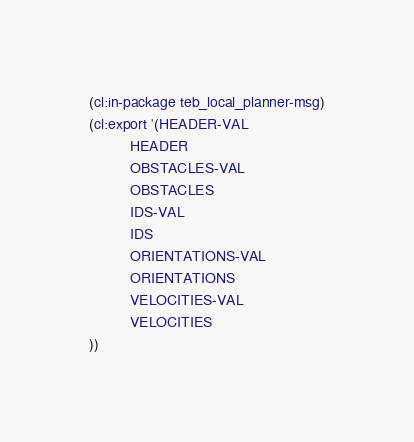<code> <loc_0><loc_0><loc_500><loc_500><_Lisp_>(cl:in-package teb_local_planner-msg)
(cl:export '(HEADER-VAL
          HEADER
          OBSTACLES-VAL
          OBSTACLES
          IDS-VAL
          IDS
          ORIENTATIONS-VAL
          ORIENTATIONS
          VELOCITIES-VAL
          VELOCITIES
))</code> 